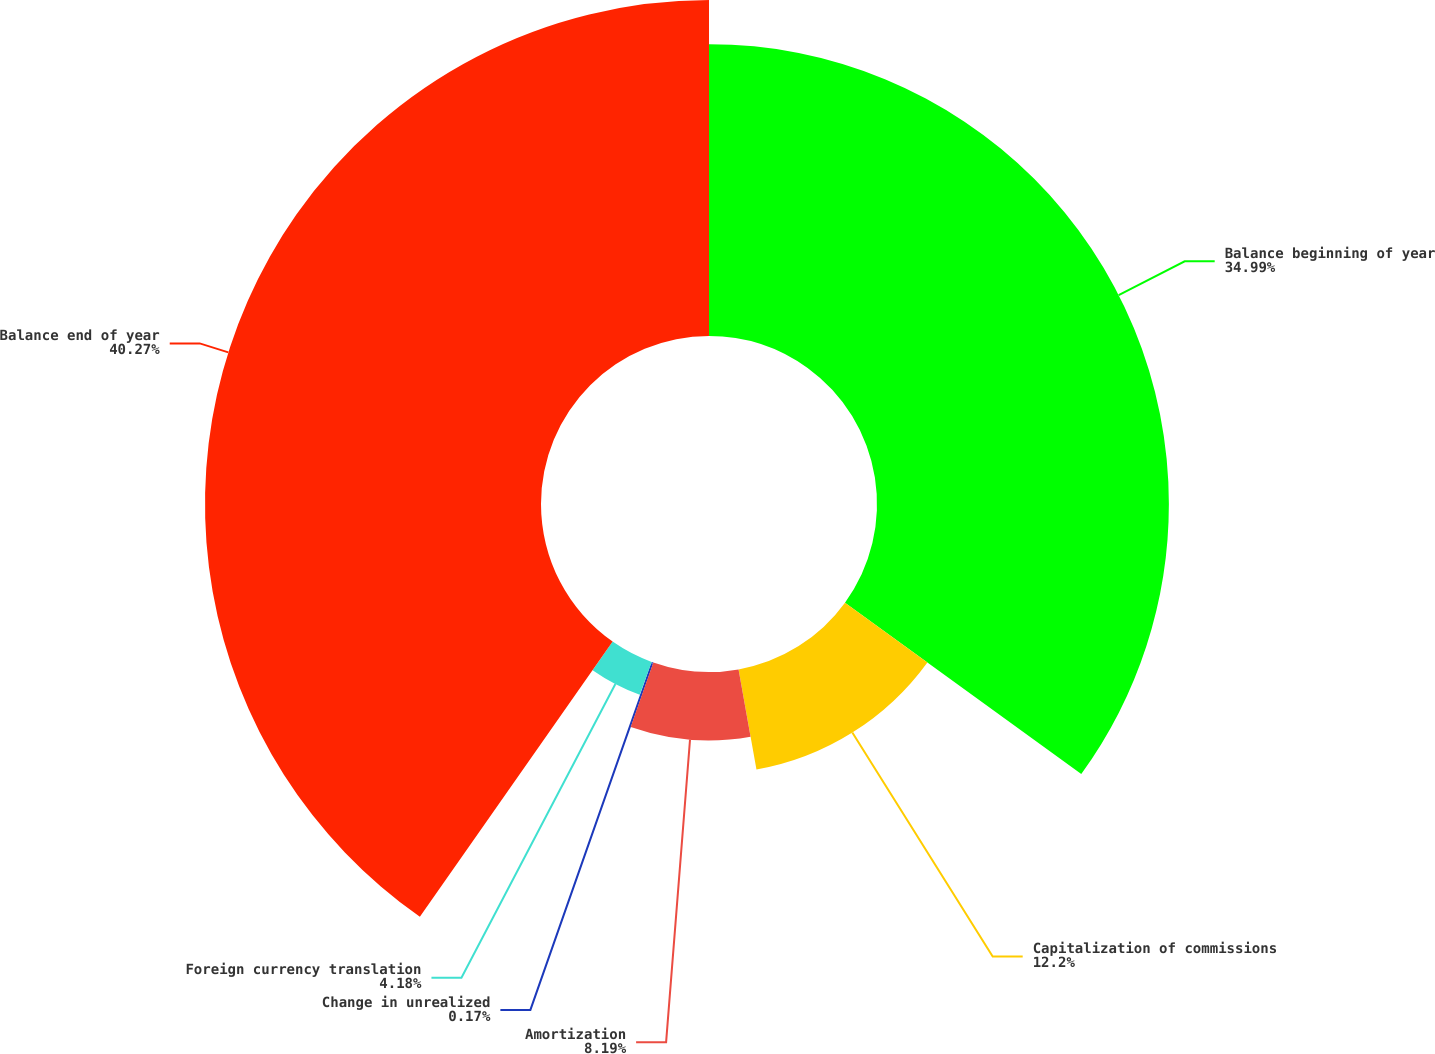Convert chart to OTSL. <chart><loc_0><loc_0><loc_500><loc_500><pie_chart><fcel>Balance beginning of year<fcel>Capitalization of commissions<fcel>Amortization<fcel>Change in unrealized<fcel>Foreign currency translation<fcel>Balance end of year<nl><fcel>34.99%<fcel>12.2%<fcel>8.19%<fcel>0.17%<fcel>4.18%<fcel>40.28%<nl></chart> 